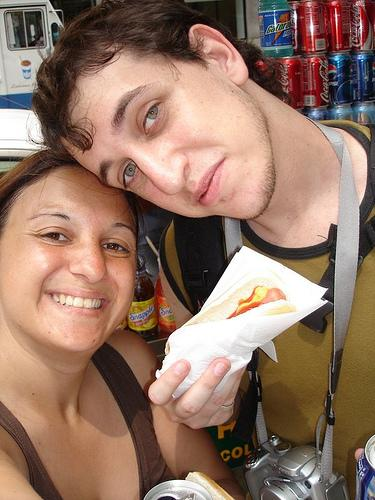What object is hanging from the man's neck? A silver digital camera is hanging from the man's neck with a strap. What type of vehicle can be seen in the image? There is a white ice cream truck visible in the image. Who is holding a hot dog and what is their appearance like? A person is holding the hot dog, who is part of a smiling couple with brown hair and brown eyes. What color is the shirt of the woman in the image? The woman is wearing a brown shirt. Mention the color and type of shirt the man in the image is wearing. The man is wearing a green tank top. What variety of drinks can be found in the image? The image features Coca Cola, Gatorade, Pepsi, Diet Coke, and Snapple drinks. Identify the type of camera in the image and mention its color. The image shows a silver-colored digital camera. Describe the hot dog in the image. The hot dog has ketchup and mustard on a bun, and is placed on a napkin. Count the number of red soda cans in the image. There are three red soda cans in the image. Is there a gold-colored camera in the image? The camera in the image is silver, not gold, so the instruction gives the wrong color. Are there any bottles of orange juice in the picture? There are bottles of Snapple in the image, not orange juice, so the instruction mentions the wrong type of drink. Is there a green can of soda in the picture? The cans of soda in the image are red, not green, so the instruction gives the wrong color. Does the man have short hair and no facial hair? The man in the image is described as having brown hair and facial hair, so the instruction is missing these details. Is the hot dog on the plate without any condiments? The hot dog in the image is described with ketchup and mustard, so the instruction omits these condiments. Is the woman in the picture wearing a blue shirt? The woman is actually wearing a brown shirt, the instruction gives the wrong color. 